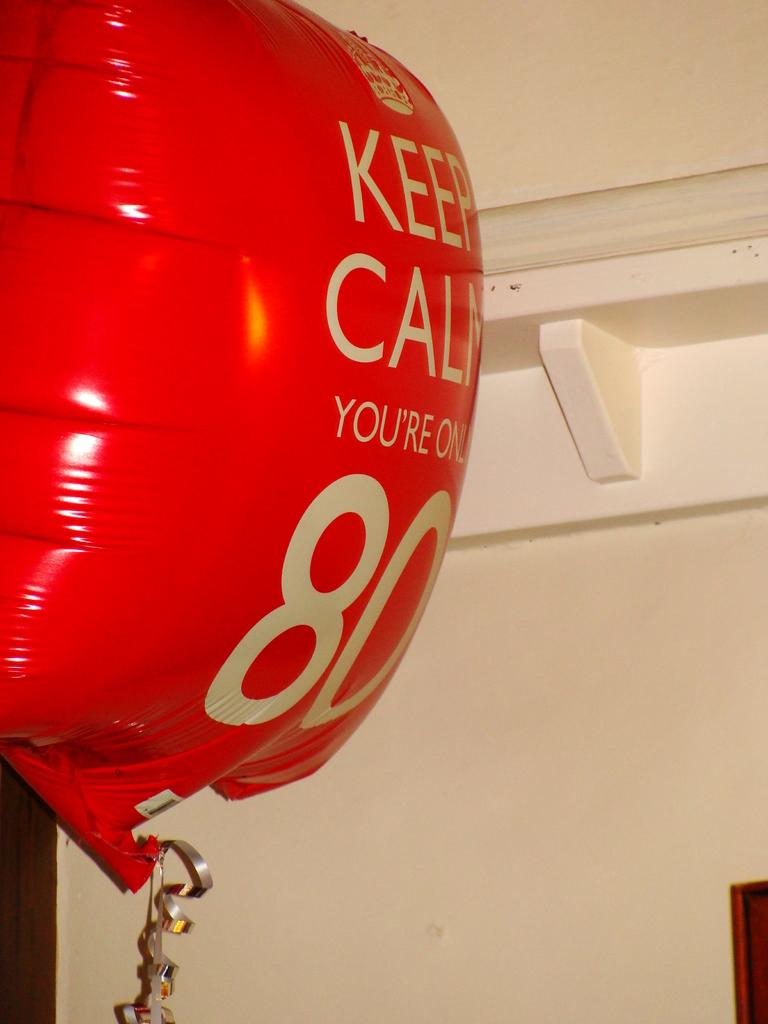<image>
Present a compact description of the photo's key features. A red balloon says Keep Calm You're Only 80. 